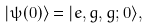Convert formula to latex. <formula><loc_0><loc_0><loc_500><loc_500>| \psi ( 0 ) \rangle = | e , g , g ; 0 \rangle ,</formula> 